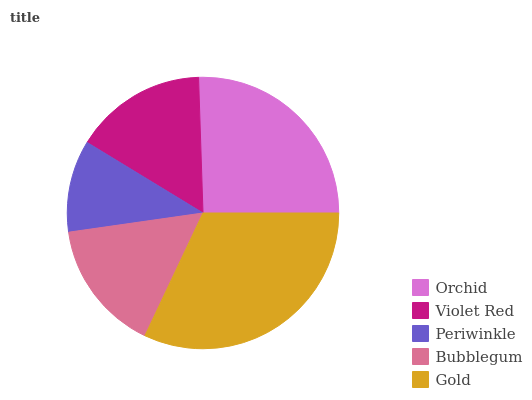Is Periwinkle the minimum?
Answer yes or no. Yes. Is Gold the maximum?
Answer yes or no. Yes. Is Violet Red the minimum?
Answer yes or no. No. Is Violet Red the maximum?
Answer yes or no. No. Is Orchid greater than Violet Red?
Answer yes or no. Yes. Is Violet Red less than Orchid?
Answer yes or no. Yes. Is Violet Red greater than Orchid?
Answer yes or no. No. Is Orchid less than Violet Red?
Answer yes or no. No. Is Violet Red the high median?
Answer yes or no. Yes. Is Violet Red the low median?
Answer yes or no. Yes. Is Periwinkle the high median?
Answer yes or no. No. Is Bubblegum the low median?
Answer yes or no. No. 